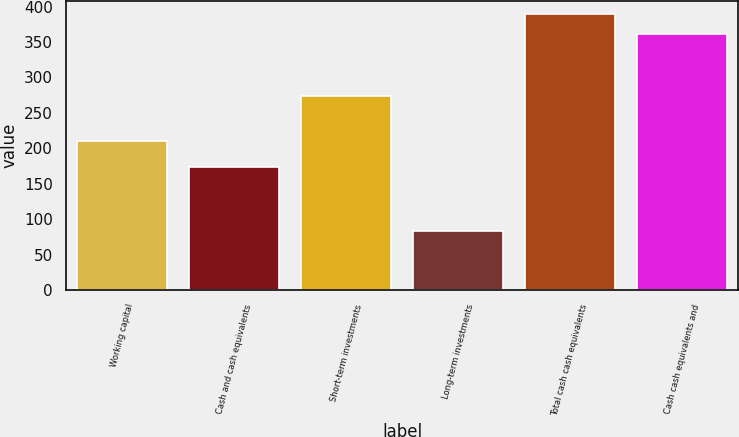Convert chart. <chart><loc_0><loc_0><loc_500><loc_500><bar_chart><fcel>Working capital<fcel>Cash and cash equivalents<fcel>Short-term investments<fcel>Long-term investments<fcel>Total cash cash equivalents<fcel>Cash cash equivalents and<nl><fcel>210.3<fcel>173.3<fcel>273.8<fcel>83.4<fcel>389.13<fcel>361.1<nl></chart> 